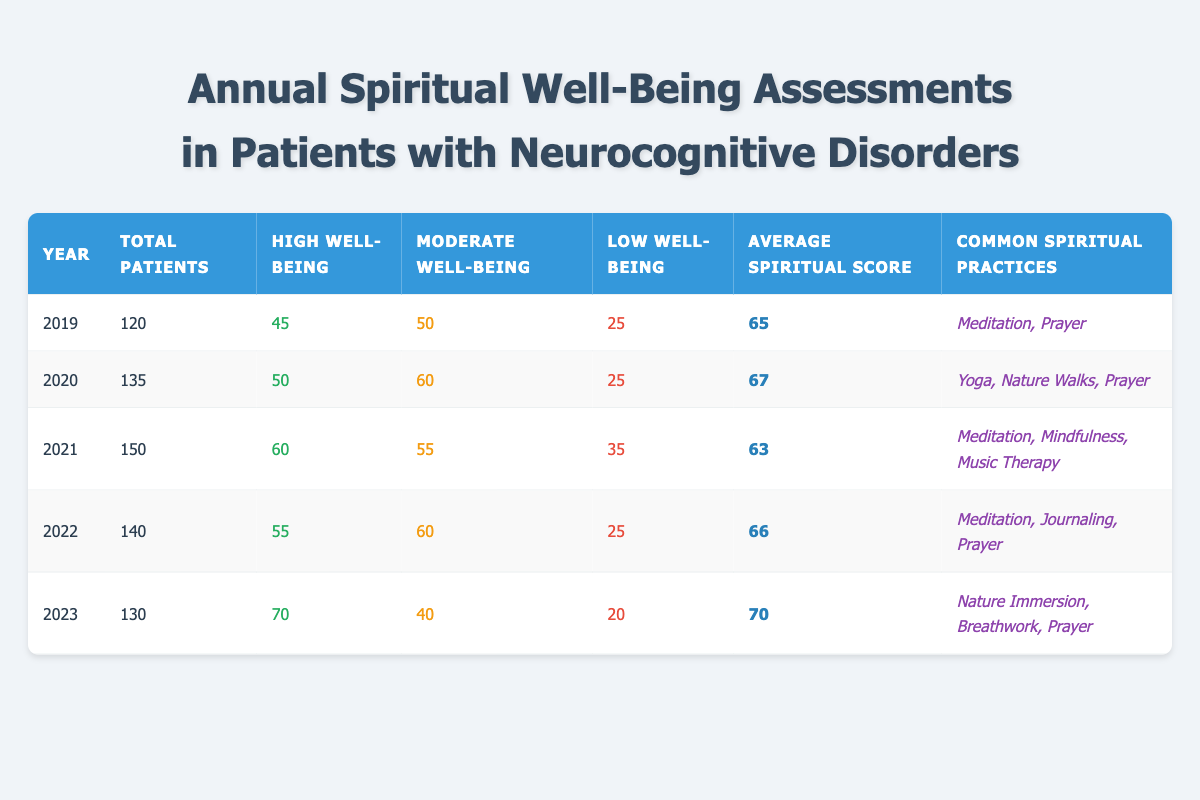What was the average spiritual score in 2020? In the table, the average spiritual score for 2020 is directly listed in the corresponding row, which is 67.
Answer: 67 How many patients had moderate well-being in 2021? Referring to the table for the year 2021, the number of patients with moderate well-being is noted as 55.
Answer: 55 What was the total number of patients in 2022? The total number of patients for 2022 can be found in the respective row of the table, which shows 140.
Answer: 140 Which year had the highest number of patients with high well-being? By examining the data for high well-being across the years, 2023 shows the highest number at 70 patients.
Answer: 2023 Did the average spiritual score increase from 2019 to 2023? To find out, we compare the average scores: 2019 had a score of 65, and 2023 had a score of 70. Since 70 > 65, the average score did increase.
Answer: Yes How many patients experienced low well-being in total from 2019 to 2023? We sum the patients with low well-being from each year: 25 (2019) + 25 (2020) + 35 (2021) + 25 (2022) + 20 (2023) = 25 + 25 + 35 + 25 + 20 = 130.
Answer: 130 What percentage of patients had high spiritual well-being in 2022? In 2022, the number of patients with high well-being is 55 out of a total of 140 patients. To find the percentage, we calculate (55/140) * 100 = 39.29%, which we can round to approximately 39%.
Answer: 39% How does the trend in common spiritual practices appear over the years? Reviewing the spiritual practices listed for each year, it appears there is a variety of practices utilized. For instance, meditation appears frequently, while in 2023, new practices like nature immersion and breathwork are introduced, indicating an evolving trend in spiritual practices.
Answer: Evolving trend What were the spiritual practices most frequently reported in the years 2020 and 2021? In 2020, the common spiritual practices were yoga, nature walks, and prayer. In 2021, they were meditation, mindfulness, and music therapy, indicating a shift towards mindfulness practices in 2021.
Answer: Yoga, nature walks, prayer and meditation, mindfulness, music therapy 